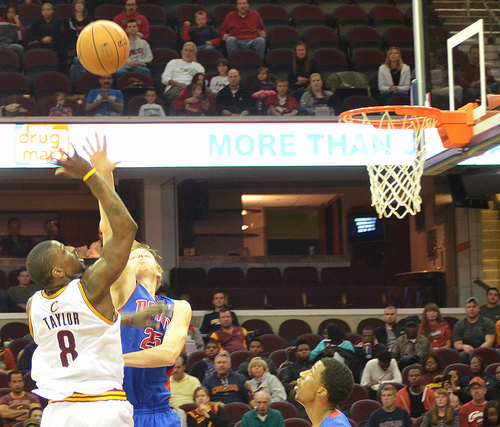<image>
Can you confirm if the fan is next to the player? No. The fan is not positioned next to the player. They are located in different areas of the scene. Is the ball above the person? Yes. The ball is positioned above the person in the vertical space, higher up in the scene. Where is the ball in relation to the person? Is it above the person? Yes. The ball is positioned above the person in the vertical space, higher up in the scene. 